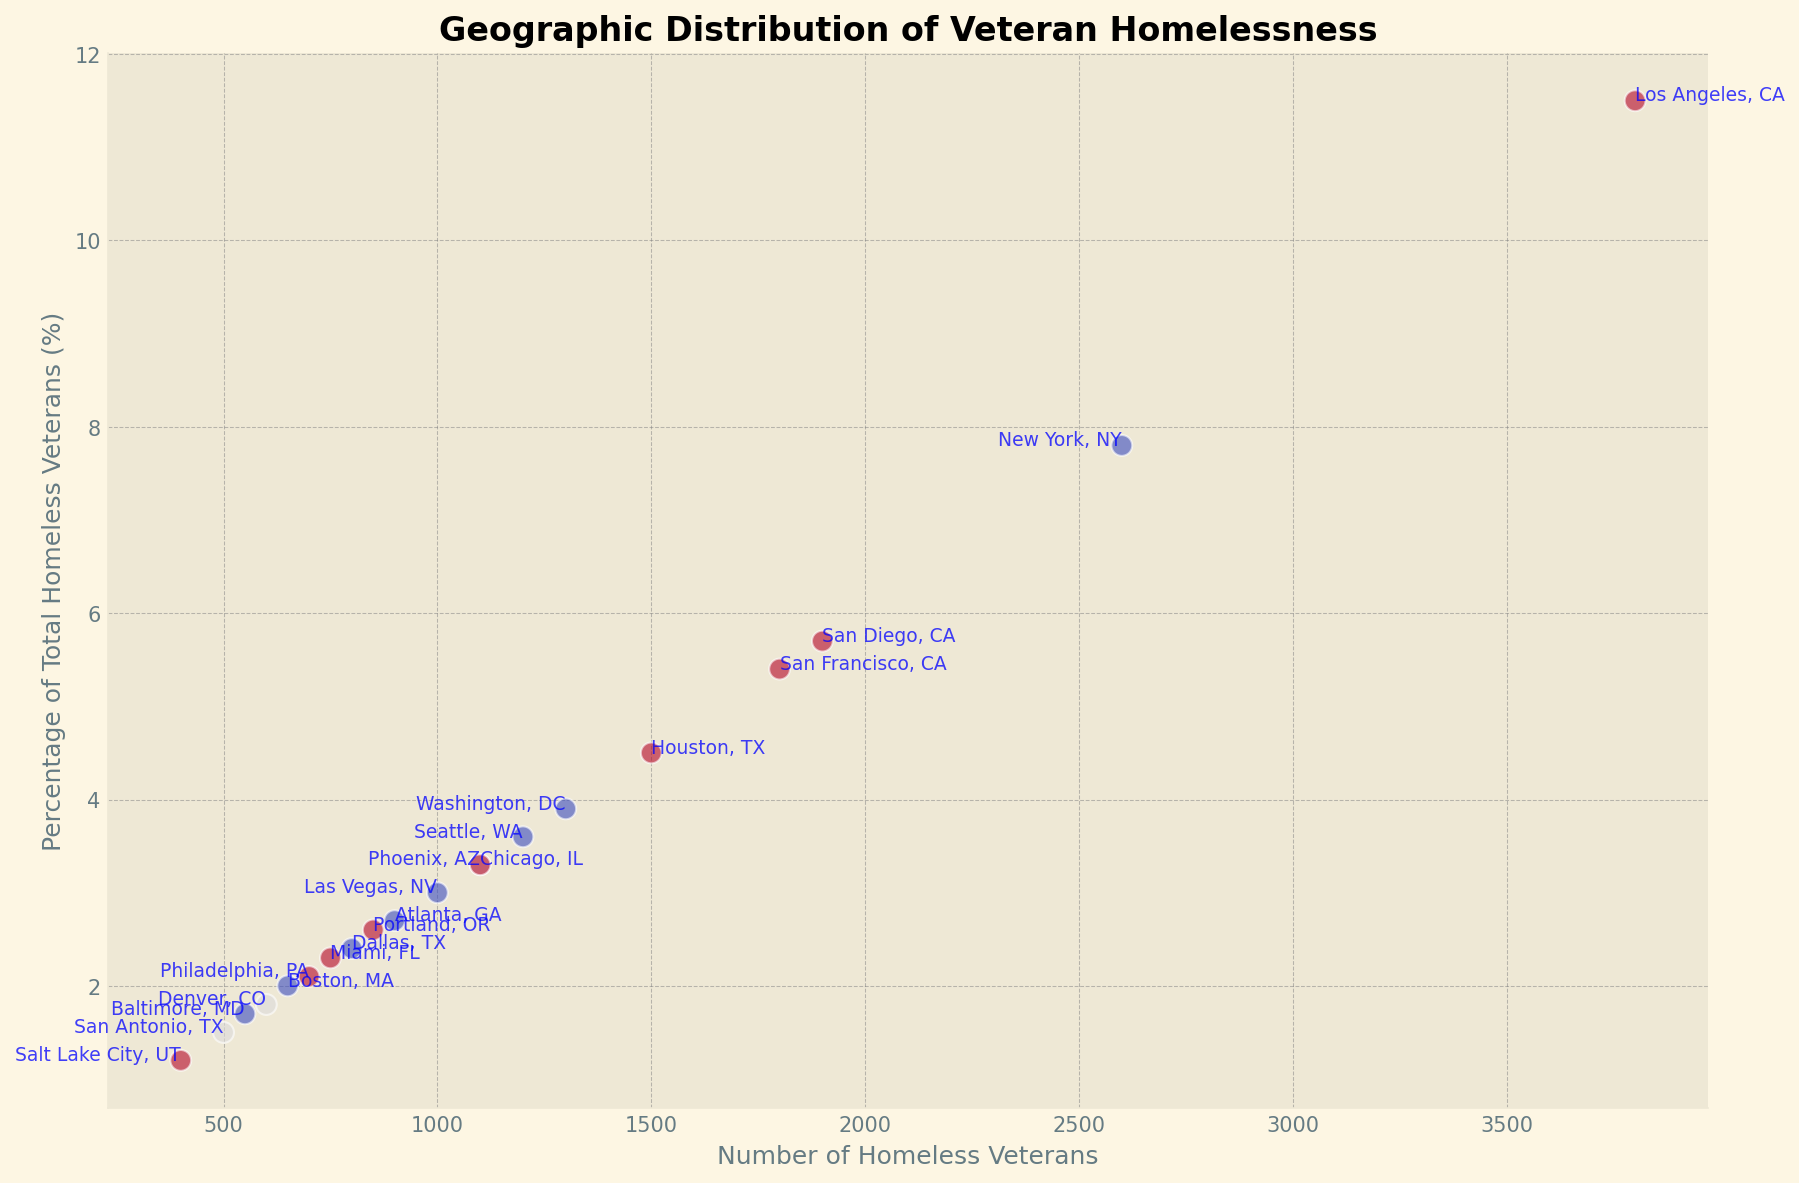Is Los Angeles experiencing an increase or decrease in the number of homeless veterans compared to last year? The annotation indicates that the percentage change since last year for Los Angeles is 0.3%, which is a positive value, meaning there is an increase.
Answer: Increase Which city has the highest percentage of total homeless veterans? By comparing the percentage values on the y-axis, we see that Los Angeles, CA, with 11.5%, has the highest percentage of total homeless veterans.
Answer: Los Angeles, CA Which city has seen the largest decrease in the number of homeless veterans? Checking the "Increase/Decrease Since Last Year" for each city, New York, NY, has the largest decrease with -1.0%.
Answer: New York, NY Which states have more than one city represented in the chart? By scanning the city and state annotations, we can see that California (Los Angeles, San Diego, and San Francisco) and Texas (Houston, Dallas, and San Antonio) each have more than one city represented.
Answer: California and Texas What is the difference in the number of homeless veterans between the city with the highest and the city with the lowest numbers? Los Angeles has the highest number with 3800 homeless veterans, and Salt Lake City has the lowest with 400. The difference is 3800 - 400 = 3400.
Answer: 3400 Compare the percentage of total homeless veterans for San Francisco, CA, and San Diego, CA. Which one is higher? According to the y-axis annotations, San Francisco, CA has 5.4%, and San Diego, CA has 5.7%, so San Diego has a higher percentage.
Answer: San Diego, CA How many cities have percentages of total homeless veterans below 3%? By counting the cities that have y-values below 3%: Las Vegas, Atlanta, Philadelphia, Dallas, Denver, Miami, Baltimore, Boston, San Antonio, and Salt Lake City. There are 10 such cities.
Answer: 10 Identify the city with 1200 homeless veterans and its percentage of the total homeless veterans. From the scatter plot, the city with 1200 homeless veterans is Seattle, WA, and its percentage of the total is 3.6%.
Answer: Seattle, WA; 3.6% Between Houston, TX, and Dallas, TX, which city has a higher number of homeless veterans, and by how much? Houston, TX has 1500 homeless veterans, and Dallas, TX has 800. The difference is 1500 - 800 = 700.
Answer: Houston, TX; 700 more Estimate the average percentage of total homeless veterans for cities in California based on the provided data. There are three cities in California: Los Angeles (11.5%), San Diego (5.7%), and San Francisco (5.4%). The average is (11.5 + 5.7 + 5.4) / 3 = 7.53%.
Answer: 7.53% 